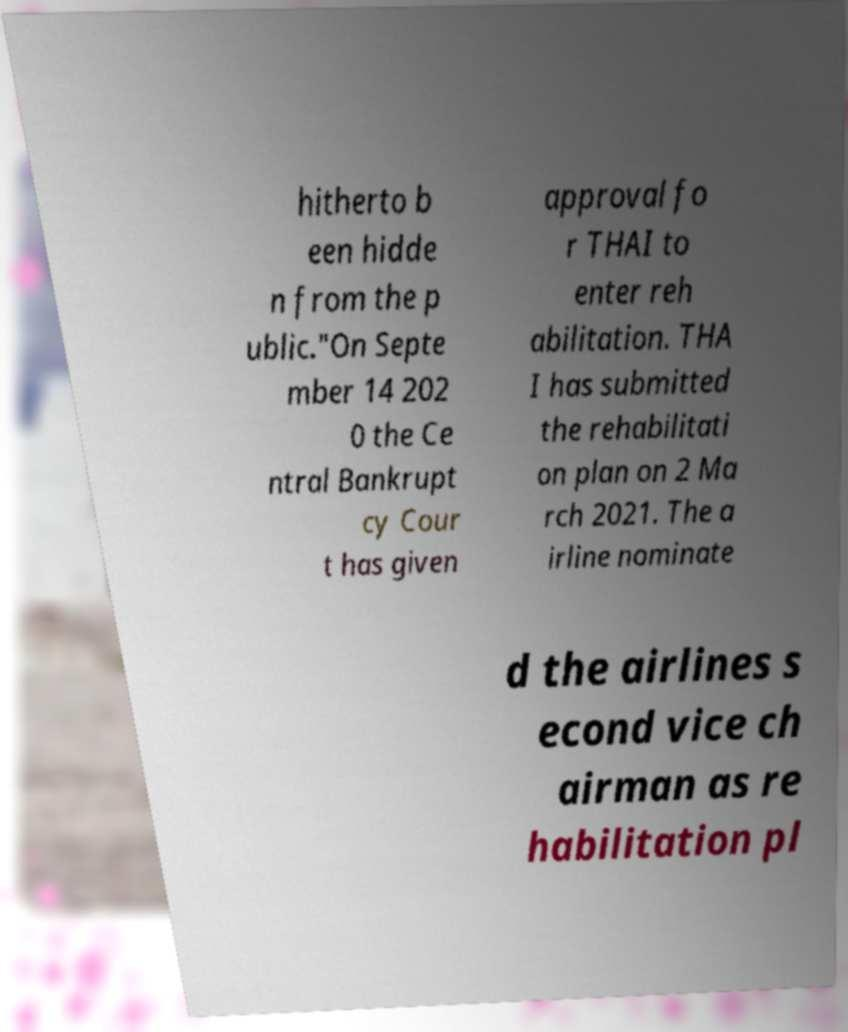Can you read and provide the text displayed in the image?This photo seems to have some interesting text. Can you extract and type it out for me? hitherto b een hidde n from the p ublic."On Septe mber 14 202 0 the Ce ntral Bankrupt cy Cour t has given approval fo r THAI to enter reh abilitation. THA I has submitted the rehabilitati on plan on 2 Ma rch 2021. The a irline nominate d the airlines s econd vice ch airman as re habilitation pl 